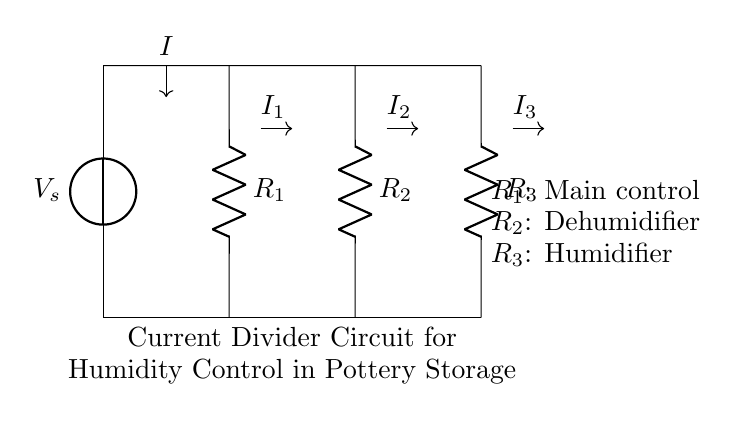What is the total current entering the circuit? The total current entering the circuit is represented by the symbol I at the input of the voltage source.
Answer: I What are the resistances in the circuit? The resistances in the circuit are labeled R1, R2, and R3, with each component distinctly marked on the diagram.
Answer: R1, R2, R3 Which resistor is used for main control? The main control resistor is labeled R1 in the circuit diagram.
Answer: R1 What is the function of R2 in this circuit? R2 is identified as the dehumidifier in the circuit diagram, indicating its role in controlling humidity levels.
Answer: Dehumidifier How does the current divide among the resistors? The current divides among the resistors based on their resistance values, where the total current I will be divided inversely proportional to the resistance of each branch.
Answer: Inversely proportional What is the significance of currents I1, I2, and I3? I1, I2, and I3 represent the individual currents through resistors R1, R2, and R3, respectively, showing how the total current I is distributed in the circuit.
Answer: Individual branch currents 